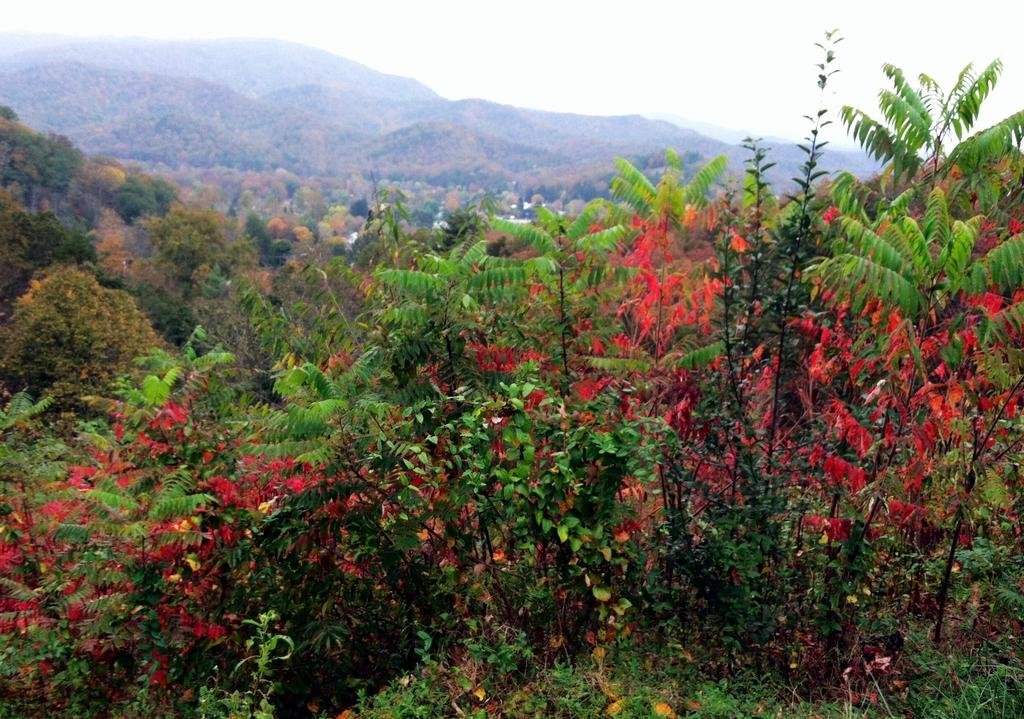What type of vegetation can be seen in the image? There are trees in the image. What geographical features are present in the image? There are hills in the image. What is visible in the background of the image? The sky is visible in the background of the image. How many pigs are lying on the linen in the image? There are no pigs or linen present in the image. What impulse caused the trees to grow in the image? The image does not provide information about the impulse that caused the trees to grow; it only shows their presence. 